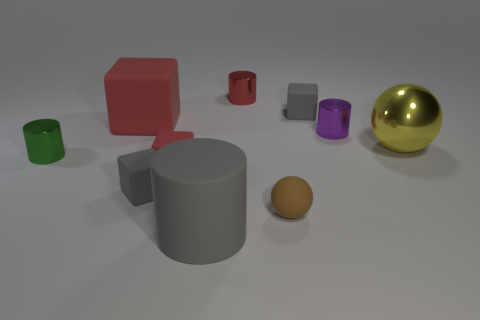There is a metallic cylinder that is the same color as the large block; what size is it?
Give a very brief answer. Small. How many rubber things are either small red blocks or brown spheres?
Make the answer very short. 2. Is the color of the big matte cylinder the same as the big rubber block?
Make the answer very short. No. Is there anything else that has the same color as the rubber sphere?
Provide a succinct answer. No. There is a metallic object on the left side of the small red metallic object; is it the same shape as the large object that is right of the small brown matte object?
Provide a succinct answer. No. What number of objects are either brown matte things or rubber cylinders on the right side of the green metal object?
Provide a short and direct response. 2. How many other things are the same size as the shiny sphere?
Keep it short and to the point. 2. Are the cube on the right side of the big gray matte object and the gray block in front of the large matte block made of the same material?
Your answer should be compact. Yes. What number of small brown rubber balls are in front of the red shiny cylinder?
Provide a succinct answer. 1. How many red things are rubber things or small rubber blocks?
Provide a short and direct response. 2. 